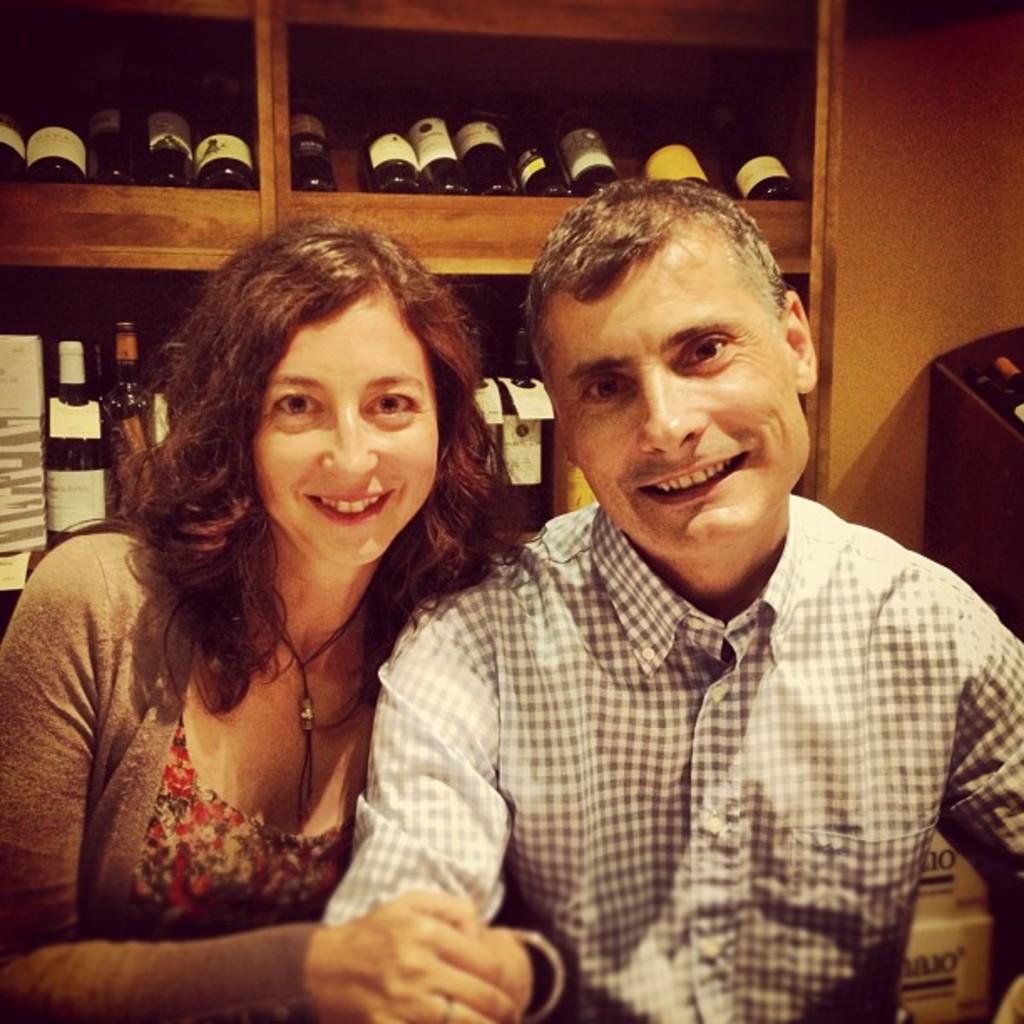Could you give a brief overview of what you see in this image? Here I can see a woman and a man are smiling and giving pose for the picture. In the background there are many bottles arranged in a rack. Beside the rock there are few objects. 